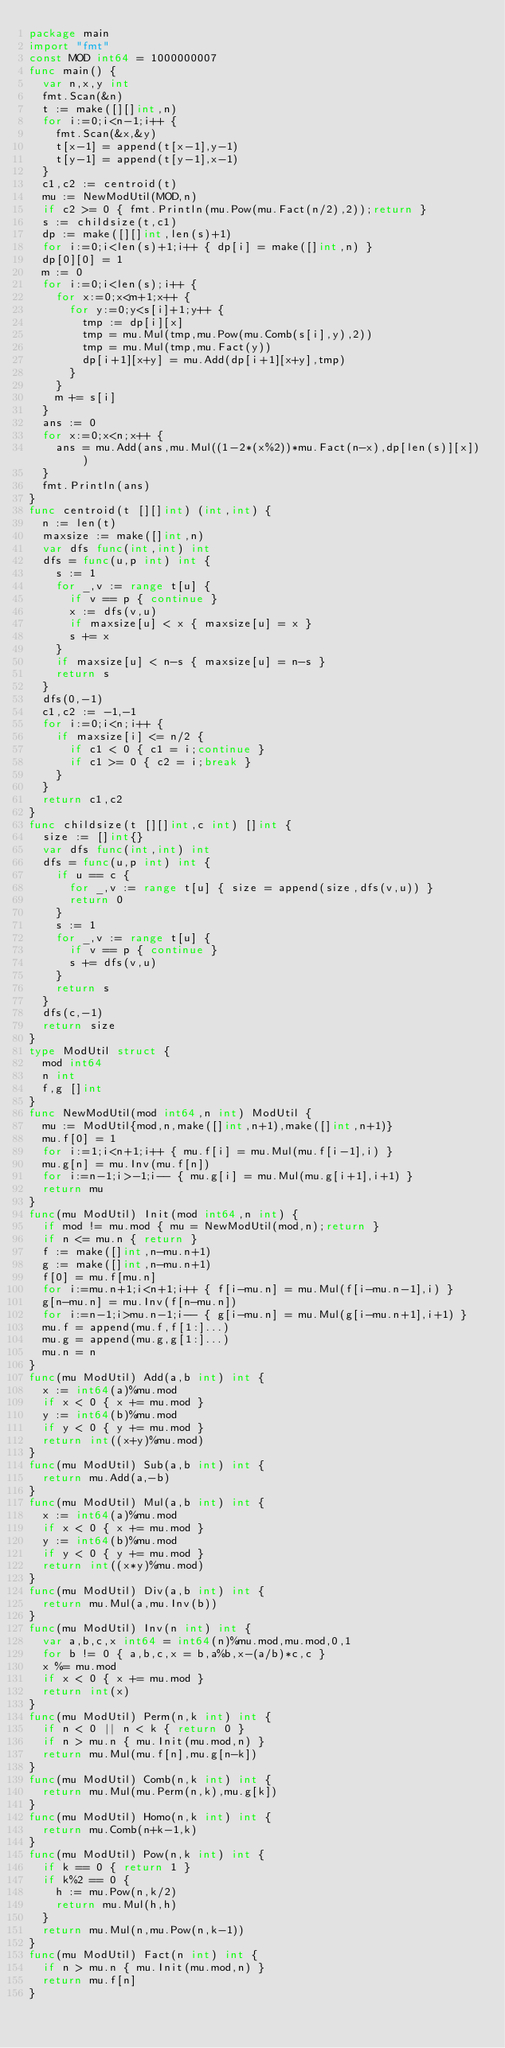<code> <loc_0><loc_0><loc_500><loc_500><_Go_>package main
import "fmt"
const MOD int64 = 1000000007
func main() {
  var n,x,y int
  fmt.Scan(&n)
  t := make([][]int,n)
  for i:=0;i<n-1;i++ {
    fmt.Scan(&x,&y)
    t[x-1] = append(t[x-1],y-1)
    t[y-1] = append(t[y-1],x-1)
  }
  c1,c2 := centroid(t)
  mu := NewModUtil(MOD,n)
  if c2 >= 0 { fmt.Println(mu.Pow(mu.Fact(n/2),2));return }
  s := childsize(t,c1)
  dp := make([][]int,len(s)+1)
  for i:=0;i<len(s)+1;i++ { dp[i] = make([]int,n) }
  dp[0][0] = 1
  m := 0
  for i:=0;i<len(s);i++ {
    for x:=0;x<m+1;x++ {
      for y:=0;y<s[i]+1;y++ {
        tmp := dp[i][x]
        tmp = mu.Mul(tmp,mu.Pow(mu.Comb(s[i],y),2))
        tmp = mu.Mul(tmp,mu.Fact(y))
        dp[i+1][x+y] = mu.Add(dp[i+1][x+y],tmp)
      }
    }
    m += s[i]
  }
  ans := 0
  for x:=0;x<n;x++ {
    ans = mu.Add(ans,mu.Mul((1-2*(x%2))*mu.Fact(n-x),dp[len(s)][x]))
  }
  fmt.Println(ans)
}
func centroid(t [][]int) (int,int) {
  n := len(t)
  maxsize := make([]int,n)
  var dfs func(int,int) int
  dfs = func(u,p int) int {
    s := 1
    for _,v := range t[u] {
      if v == p { continue }
      x := dfs(v,u)
      if maxsize[u] < x { maxsize[u] = x }
      s += x
    }
    if maxsize[u] < n-s { maxsize[u] = n-s }
    return s
  }
  dfs(0,-1)
  c1,c2 := -1,-1
  for i:=0;i<n;i++ {
    if maxsize[i] <= n/2 {
      if c1 < 0 { c1 = i;continue }
      if c1 >= 0 { c2 = i;break }
    }
  }
  return c1,c2
}
func childsize(t [][]int,c int) []int {
  size := []int{}
  var dfs func(int,int) int
  dfs = func(u,p int) int {
    if u == c {
      for _,v := range t[u] { size = append(size,dfs(v,u)) }
      return 0
    }
    s := 1
    for _,v := range t[u] {
      if v == p { continue }
      s += dfs(v,u)
    }
    return s
  }
  dfs(c,-1)
  return size
}
type ModUtil struct {
  mod int64
  n int
  f,g []int
}
func NewModUtil(mod int64,n int) ModUtil {
  mu := ModUtil{mod,n,make([]int,n+1),make([]int,n+1)}
  mu.f[0] = 1
  for i:=1;i<n+1;i++ { mu.f[i] = mu.Mul(mu.f[i-1],i) }
  mu.g[n] = mu.Inv(mu.f[n])
  for i:=n-1;i>-1;i-- { mu.g[i] = mu.Mul(mu.g[i+1],i+1) }
  return mu
}
func(mu ModUtil) Init(mod int64,n int) {
  if mod != mu.mod { mu = NewModUtil(mod,n);return }
  if n <= mu.n { return }
  f := make([]int,n-mu.n+1)
  g := make([]int,n-mu.n+1)
  f[0] = mu.f[mu.n]
  for i:=mu.n+1;i<n+1;i++ { f[i-mu.n] = mu.Mul(f[i-mu.n-1],i) }
  g[n-mu.n] = mu.Inv(f[n-mu.n])
  for i:=n-1;i>mu.n-1;i-- { g[i-mu.n] = mu.Mul(g[i-mu.n+1],i+1) }
  mu.f = append(mu.f,f[1:]...)
  mu.g = append(mu.g,g[1:]...)
  mu.n = n
}
func(mu ModUtil) Add(a,b int) int {
  x := int64(a)%mu.mod
  if x < 0 { x += mu.mod }
  y := int64(b)%mu.mod
  if y < 0 { y += mu.mod }
  return int((x+y)%mu.mod)
}
func(mu ModUtil) Sub(a,b int) int {
  return mu.Add(a,-b)
}
func(mu ModUtil) Mul(a,b int) int {
  x := int64(a)%mu.mod
  if x < 0 { x += mu.mod }
  y := int64(b)%mu.mod
  if y < 0 { y += mu.mod }
  return int((x*y)%mu.mod)
}
func(mu ModUtil) Div(a,b int) int {
  return mu.Mul(a,mu.Inv(b))
}
func(mu ModUtil) Inv(n int) int {
  var a,b,c,x int64 = int64(n)%mu.mod,mu.mod,0,1
  for b != 0 { a,b,c,x = b,a%b,x-(a/b)*c,c }
  x %= mu.mod
  if x < 0 { x += mu.mod }
  return int(x)
}
func(mu ModUtil) Perm(n,k int) int {
  if n < 0 || n < k { return 0 }
  if n > mu.n { mu.Init(mu.mod,n) }
  return mu.Mul(mu.f[n],mu.g[n-k])
}
func(mu ModUtil) Comb(n,k int) int {
  return mu.Mul(mu.Perm(n,k),mu.g[k])
}
func(mu ModUtil) Homo(n,k int) int {
  return mu.Comb(n+k-1,k)
}
func(mu ModUtil) Pow(n,k int) int {
  if k == 0 { return 1 }
  if k%2 == 0 {
    h := mu.Pow(n,k/2)
    return mu.Mul(h,h)
  }
  return mu.Mul(n,mu.Pow(n,k-1))
}
func(mu ModUtil) Fact(n int) int {
  if n > mu.n { mu.Init(mu.mod,n) }
  return mu.f[n]
}</code> 